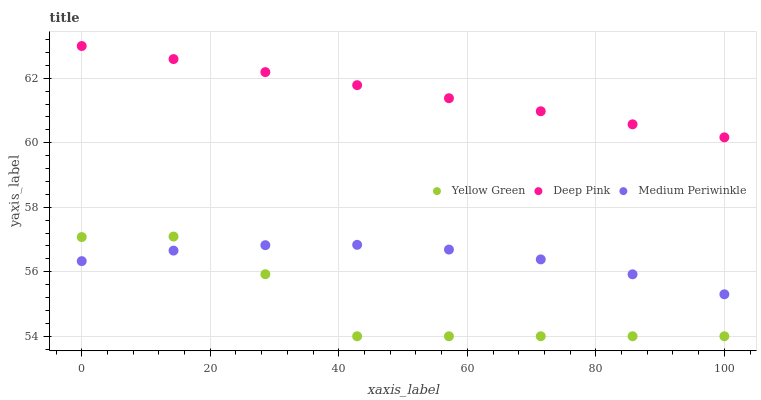Does Yellow Green have the minimum area under the curve?
Answer yes or no. Yes. Does Deep Pink have the maximum area under the curve?
Answer yes or no. Yes. Does Medium Periwinkle have the minimum area under the curve?
Answer yes or no. No. Does Medium Periwinkle have the maximum area under the curve?
Answer yes or no. No. Is Deep Pink the smoothest?
Answer yes or no. Yes. Is Yellow Green the roughest?
Answer yes or no. Yes. Is Medium Periwinkle the smoothest?
Answer yes or no. No. Is Medium Periwinkle the roughest?
Answer yes or no. No. Does Yellow Green have the lowest value?
Answer yes or no. Yes. Does Medium Periwinkle have the lowest value?
Answer yes or no. No. Does Deep Pink have the highest value?
Answer yes or no. Yes. Does Yellow Green have the highest value?
Answer yes or no. No. Is Yellow Green less than Deep Pink?
Answer yes or no. Yes. Is Deep Pink greater than Yellow Green?
Answer yes or no. Yes. Does Yellow Green intersect Medium Periwinkle?
Answer yes or no. Yes. Is Yellow Green less than Medium Periwinkle?
Answer yes or no. No. Is Yellow Green greater than Medium Periwinkle?
Answer yes or no. No. Does Yellow Green intersect Deep Pink?
Answer yes or no. No. 